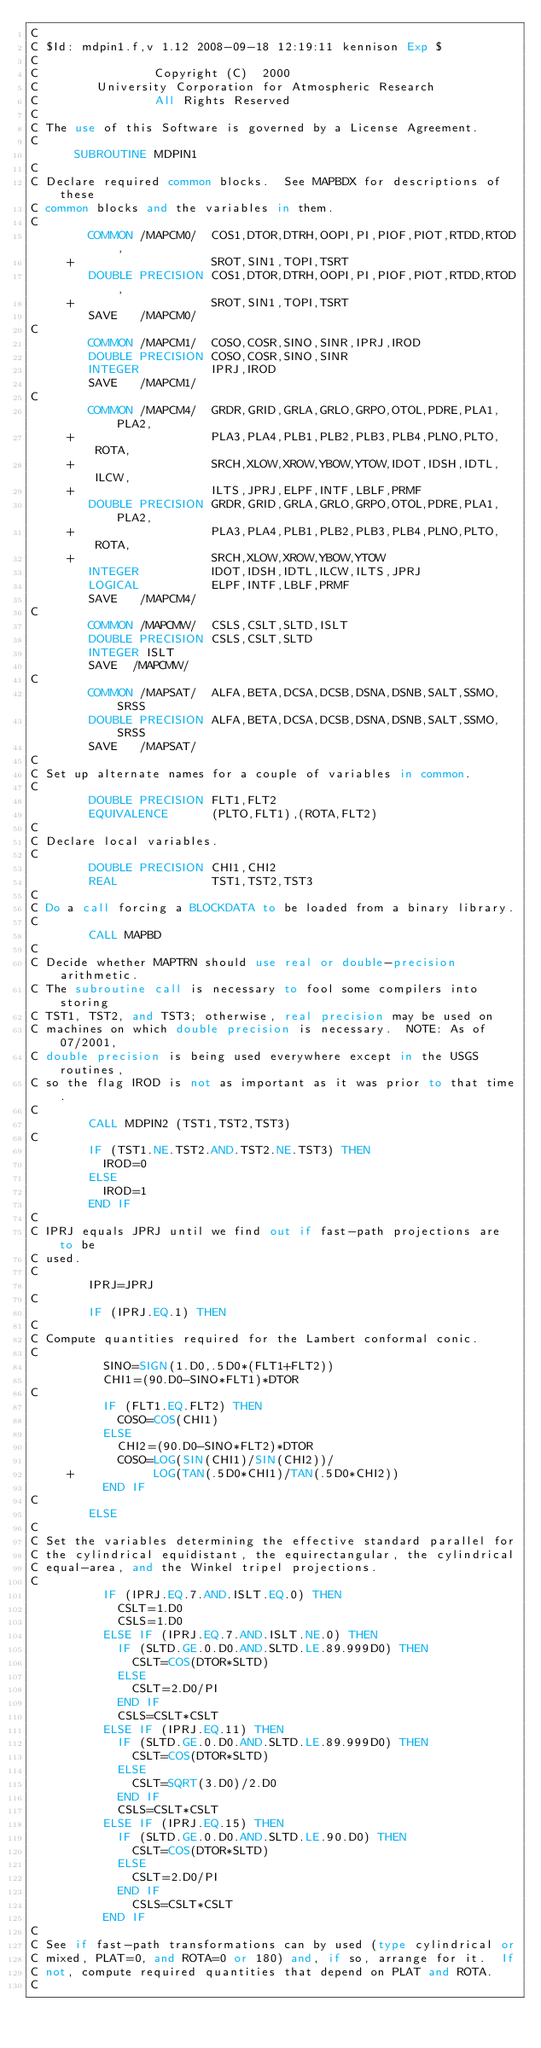<code> <loc_0><loc_0><loc_500><loc_500><_FORTRAN_>C
C $Id: mdpin1.f,v 1.12 2008-09-18 12:19:11 kennison Exp $
C
C                Copyright (C)  2000
C        University Corporation for Atmospheric Research
C                All Rights Reserved
C
C The use of this Software is governed by a License Agreement.
C
      SUBROUTINE MDPIN1
C
C Declare required common blocks.  See MAPBDX for descriptions of these
C common blocks and the variables in them.
C
        COMMON /MAPCM0/  COS1,DTOR,DTRH,OOPI,PI,PIOF,PIOT,RTDD,RTOD,
     +                   SROT,SIN1,TOPI,TSRT
        DOUBLE PRECISION COS1,DTOR,DTRH,OOPI,PI,PIOF,PIOT,RTDD,RTOD,
     +                   SROT,SIN1,TOPI,TSRT
        SAVE   /MAPCM0/
C
        COMMON /MAPCM1/  COSO,COSR,SINO,SINR,IPRJ,IROD
        DOUBLE PRECISION COSO,COSR,SINO,SINR
        INTEGER          IPRJ,IROD
        SAVE   /MAPCM1/
C
        COMMON /MAPCM4/  GRDR,GRID,GRLA,GRLO,GRPO,OTOL,PDRE,PLA1,PLA2,
     +                   PLA3,PLA4,PLB1,PLB2,PLB3,PLB4,PLNO,PLTO,ROTA,
     +                   SRCH,XLOW,XROW,YBOW,YTOW,IDOT,IDSH,IDTL,ILCW,
     +                   ILTS,JPRJ,ELPF,INTF,LBLF,PRMF
        DOUBLE PRECISION GRDR,GRID,GRLA,GRLO,GRPO,OTOL,PDRE,PLA1,PLA2,
     +                   PLA3,PLA4,PLB1,PLB2,PLB3,PLB4,PLNO,PLTO,ROTA,
     +                   SRCH,XLOW,XROW,YBOW,YTOW
        INTEGER          IDOT,IDSH,IDTL,ILCW,ILTS,JPRJ
        LOGICAL          ELPF,INTF,LBLF,PRMF
        SAVE   /MAPCM4/
C
        COMMON /MAPCMW/  CSLS,CSLT,SLTD,ISLT
        DOUBLE PRECISION CSLS,CSLT,SLTD
        INTEGER ISLT
        SAVE  /MAPCMW/
C
        COMMON /MAPSAT/  ALFA,BETA,DCSA,DCSB,DSNA,DSNB,SALT,SSMO,SRSS
        DOUBLE PRECISION ALFA,BETA,DCSA,DCSB,DSNA,DSNB,SALT,SSMO,SRSS
        SAVE   /MAPSAT/
C
C Set up alternate names for a couple of variables in common.
C
        DOUBLE PRECISION FLT1,FLT2
        EQUIVALENCE      (PLTO,FLT1),(ROTA,FLT2)
C
C Declare local variables.
C
        DOUBLE PRECISION CHI1,CHI2
        REAL             TST1,TST2,TST3
C
C Do a call forcing a BLOCKDATA to be loaded from a binary library.
C
        CALL MAPBD
C
C Decide whether MAPTRN should use real or double-precision arithmetic.
C The subroutine call is necessary to fool some compilers into storing
C TST1, TST2, and TST3; otherwise, real precision may be used on
C machines on which double precision is necessary.  NOTE: As of 07/2001,
C double precision is being used everywhere except in the USGS routines,
C so the flag IROD is not as important as it was prior to that time.
C
        CALL MDPIN2 (TST1,TST2,TST3)
C
        IF (TST1.NE.TST2.AND.TST2.NE.TST3) THEN
          IROD=0
        ELSE
          IROD=1
        END IF
C
C IPRJ equals JPRJ until we find out if fast-path projections are to be
C used.
C
        IPRJ=JPRJ
C
        IF (IPRJ.EQ.1) THEN
C
C Compute quantities required for the Lambert conformal conic.
C
          SINO=SIGN(1.D0,.5D0*(FLT1+FLT2))
          CHI1=(90.D0-SINO*FLT1)*DTOR
C
          IF (FLT1.EQ.FLT2) THEN
            COSO=COS(CHI1)
          ELSE
            CHI2=(90.D0-SINO*FLT2)*DTOR
            COSO=LOG(SIN(CHI1)/SIN(CHI2))/
     +           LOG(TAN(.5D0*CHI1)/TAN(.5D0*CHI2))
          END IF
C
        ELSE
C
C Set the variables determining the effective standard parallel for
C the cylindrical equidistant, the equirectangular, the cylindrical
C equal-area, and the Winkel tripel projections.
C
          IF (IPRJ.EQ.7.AND.ISLT.EQ.0) THEN
            CSLT=1.D0
            CSLS=1.D0
          ELSE IF (IPRJ.EQ.7.AND.ISLT.NE.0) THEN
            IF (SLTD.GE.0.D0.AND.SLTD.LE.89.999D0) THEN
              CSLT=COS(DTOR*SLTD)
            ELSE
              CSLT=2.D0/PI
            END IF
            CSLS=CSLT*CSLT
          ELSE IF (IPRJ.EQ.11) THEN
            IF (SLTD.GE.0.D0.AND.SLTD.LE.89.999D0) THEN
              CSLT=COS(DTOR*SLTD)
            ELSE
              CSLT=SQRT(3.D0)/2.D0
            END IF
            CSLS=CSLT*CSLT
          ELSE IF (IPRJ.EQ.15) THEN
            IF (SLTD.GE.0.D0.AND.SLTD.LE.90.D0) THEN
              CSLT=COS(DTOR*SLTD)
            ELSE
              CSLT=2.D0/PI
            END IF
              CSLS=CSLT*CSLT
          END IF
C
C See if fast-path transformations can by used (type cylindrical or
C mixed, PLAT=0, and ROTA=0 or 180) and, if so, arrange for it.  If
C not, compute required quantities that depend on PLAT and ROTA.
C</code> 